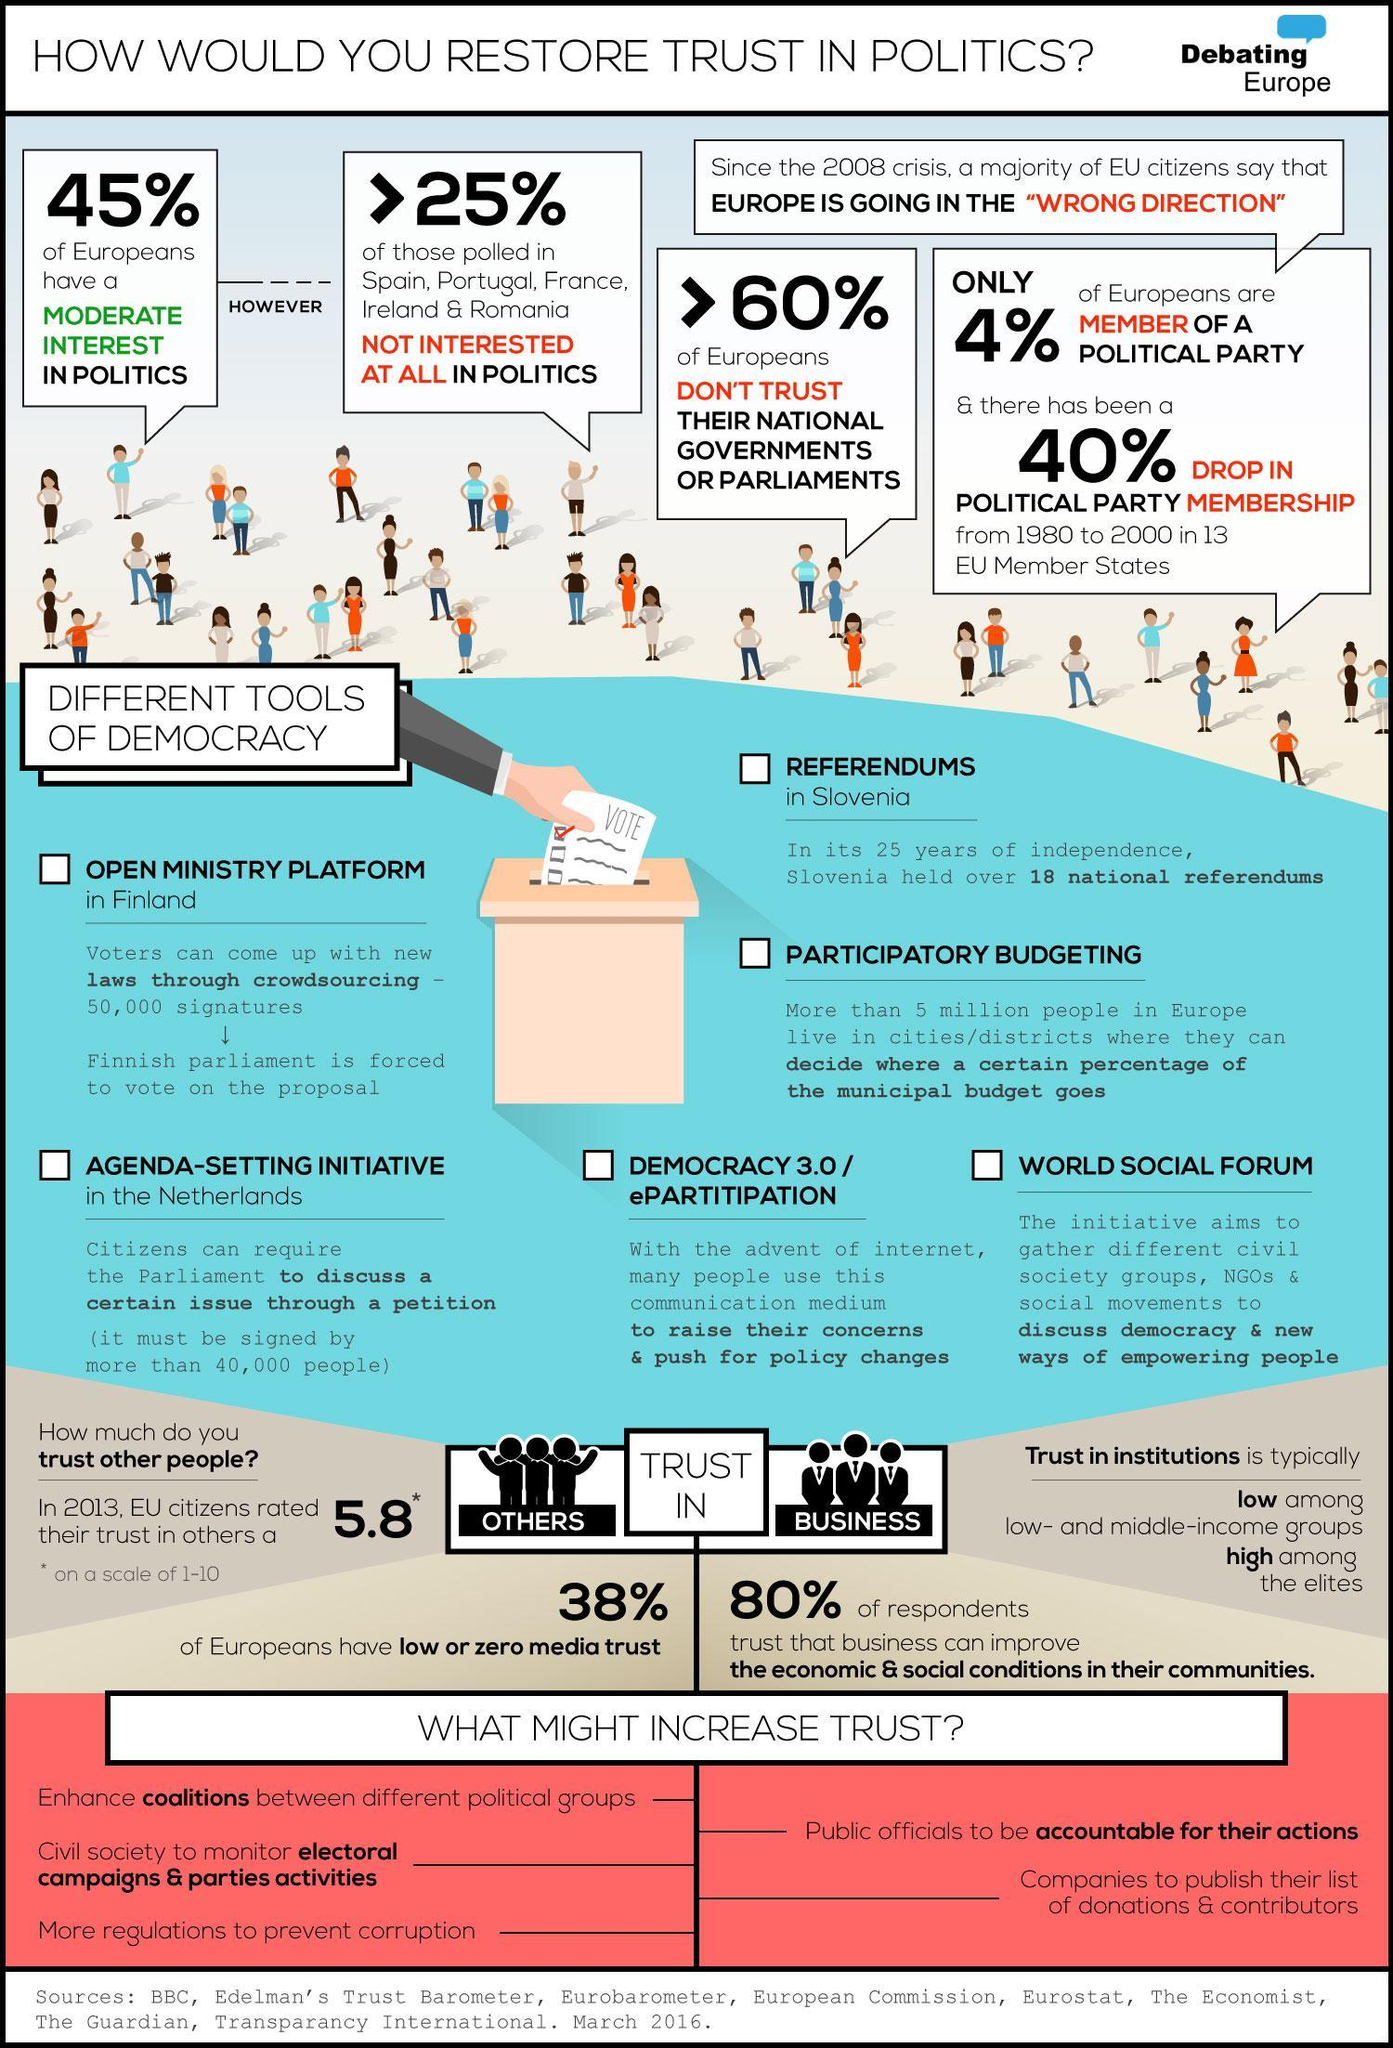Where can various groups gather to discuss democracy and ways to empower people?
Answer the question with a short phrase. world social forum What percent of people in some EU countries are least interested in politics? >25% What is used  by people to raise concerns and push for policy changes? internet What percent of Europeans are moderately interested in politics? 45% A proposal should be signed by how many people to be voted in Finnish parliament? 50,000 A minimum of how many signatures are required in a petition to discuss an issue in parliament? 40,000 